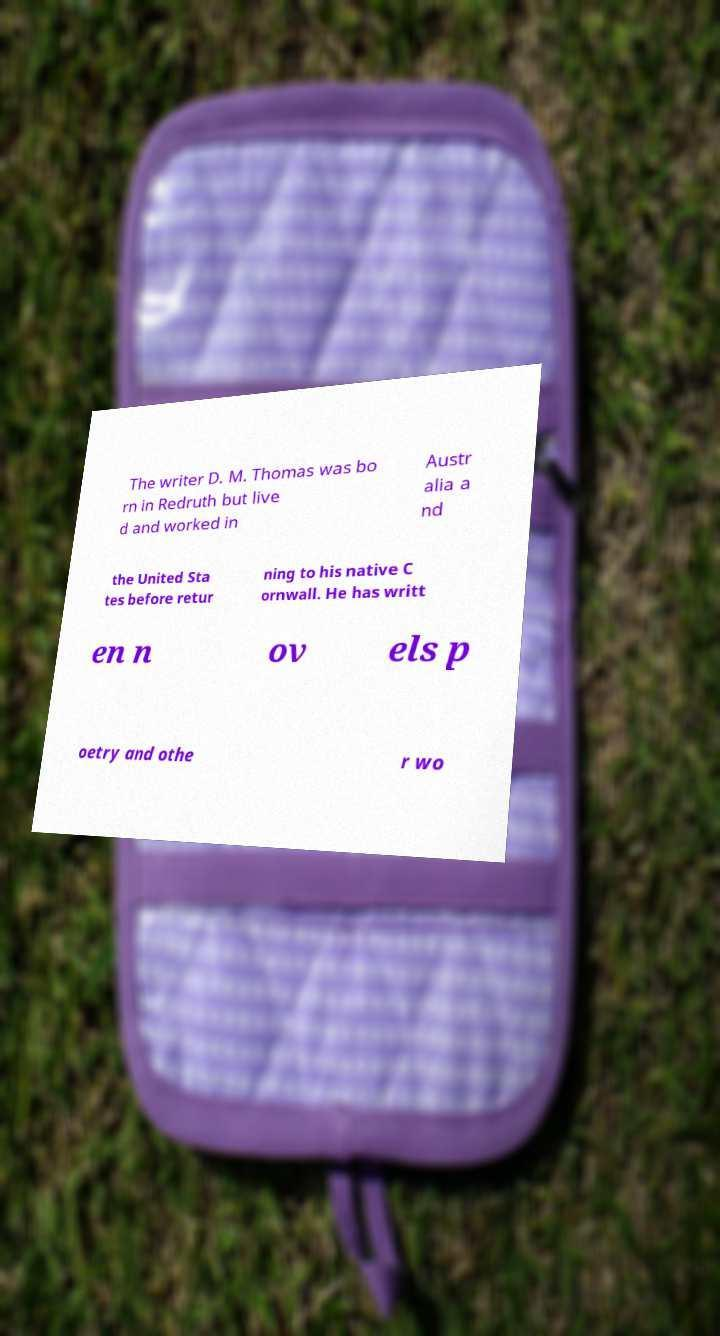Please identify and transcribe the text found in this image. The writer D. M. Thomas was bo rn in Redruth but live d and worked in Austr alia a nd the United Sta tes before retur ning to his native C ornwall. He has writt en n ov els p oetry and othe r wo 